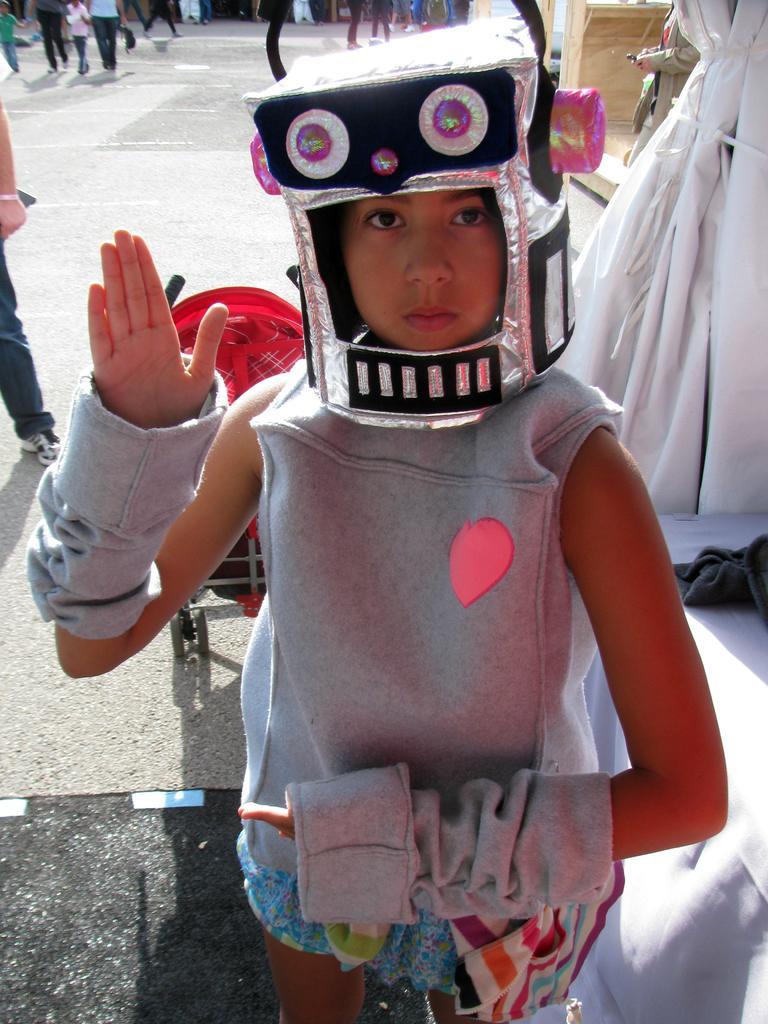Can you describe this image briefly? In the image we can see a child wearing clothes and a robot mask. This is a footpath and there are other people wearing clothes and shoes, they are walking. 